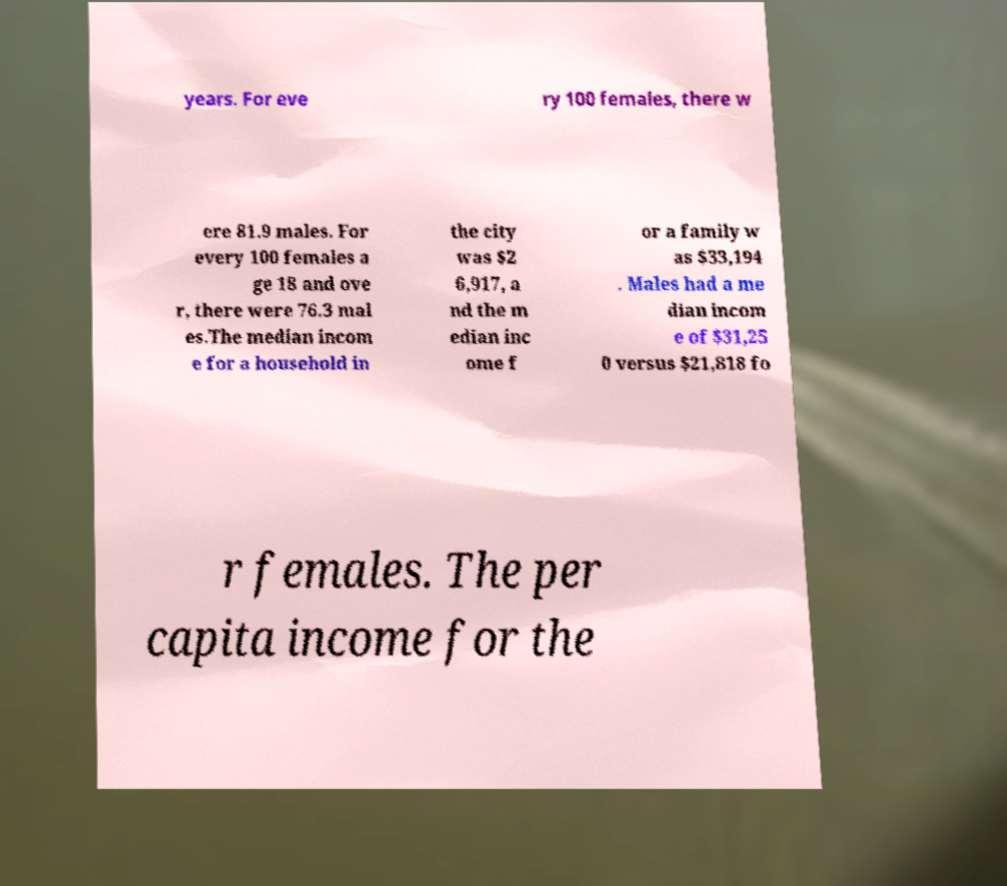There's text embedded in this image that I need extracted. Can you transcribe it verbatim? years. For eve ry 100 females, there w ere 81.9 males. For every 100 females a ge 18 and ove r, there were 76.3 mal es.The median incom e for a household in the city was $2 6,917, a nd the m edian inc ome f or a family w as $33,194 . Males had a me dian incom e of $31,25 0 versus $21,818 fo r females. The per capita income for the 